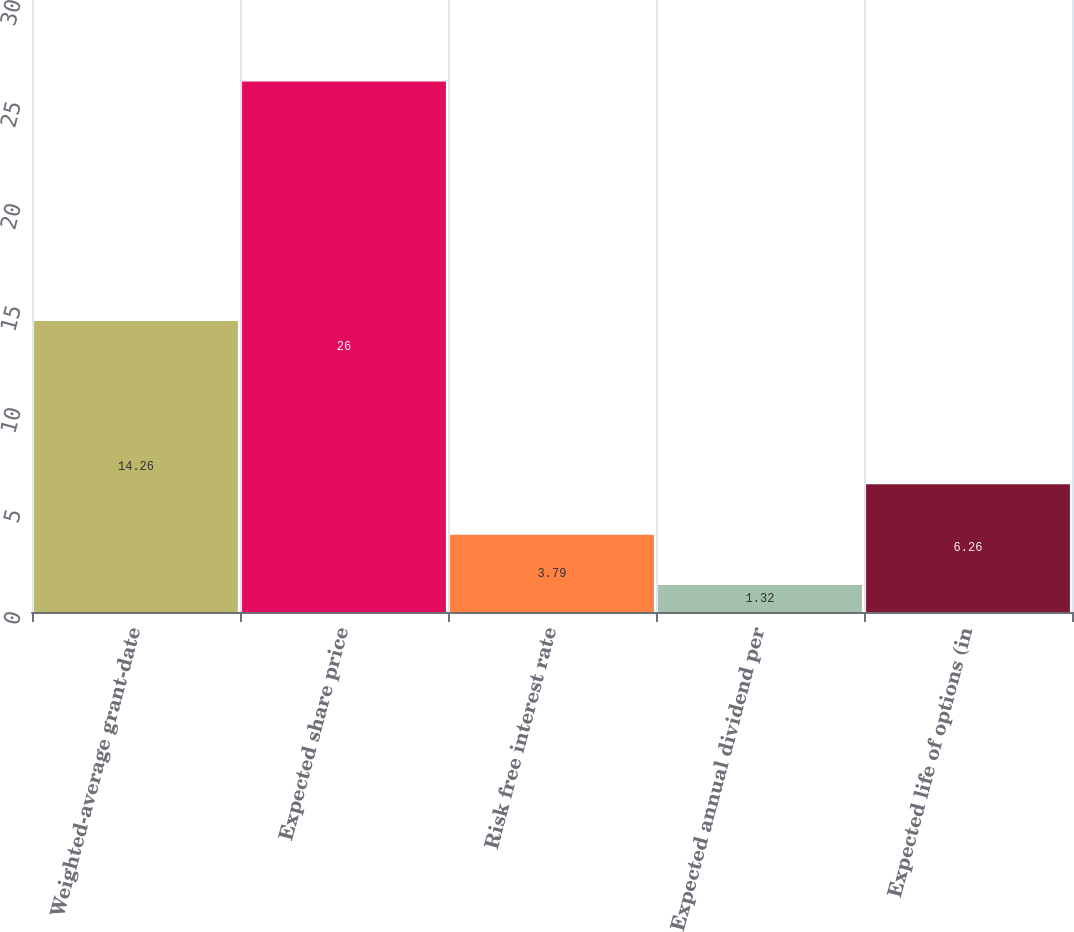<chart> <loc_0><loc_0><loc_500><loc_500><bar_chart><fcel>Weighted-average grant-date<fcel>Expected share price<fcel>Risk free interest rate<fcel>Expected annual dividend per<fcel>Expected life of options (in<nl><fcel>14.26<fcel>26<fcel>3.79<fcel>1.32<fcel>6.26<nl></chart> 